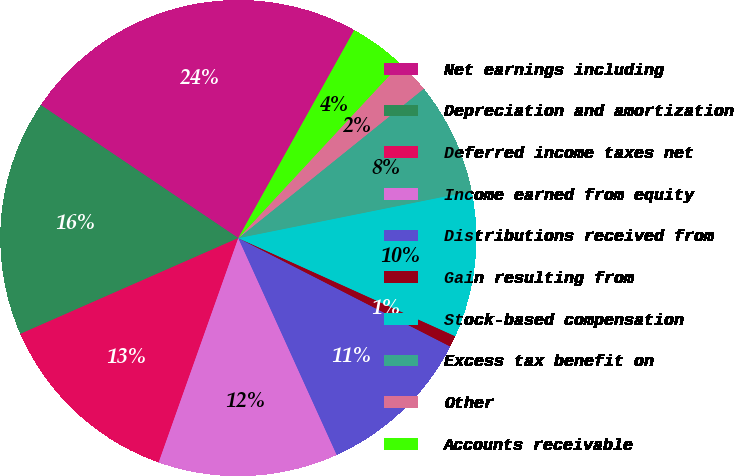Convert chart. <chart><loc_0><loc_0><loc_500><loc_500><pie_chart><fcel>Net earnings including<fcel>Depreciation and amortization<fcel>Deferred income taxes net<fcel>Income earned from equity<fcel>Distributions received from<fcel>Gain resulting from<fcel>Stock-based compensation<fcel>Excess tax benefit on<fcel>Other<fcel>Accounts receivable<nl><fcel>23.66%<fcel>16.03%<fcel>12.98%<fcel>12.21%<fcel>10.69%<fcel>0.77%<fcel>9.92%<fcel>7.63%<fcel>2.29%<fcel>3.82%<nl></chart> 